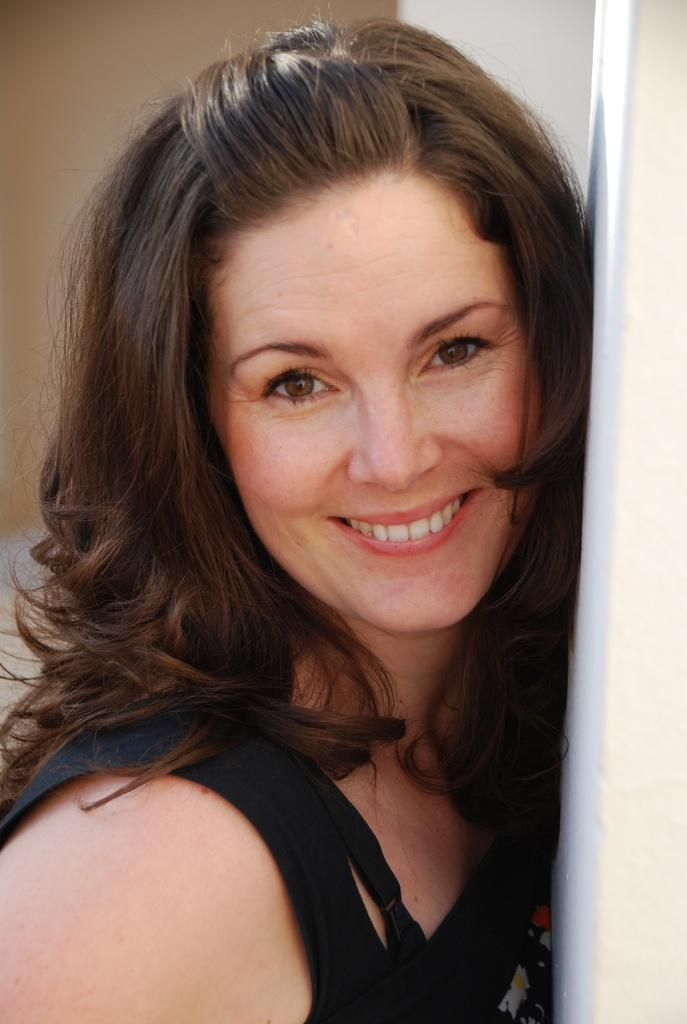Who is the main subject in the image? There is a woman in the image. What is the woman wearing? The woman is wearing a black top. What is the woman doing in the image? The woman is posing for a photograph. What type of destruction can be seen in the image? There is no destruction present in the image; it features a woman posing for a photograph. How much salt is visible in the image? There is no salt present in the image. 